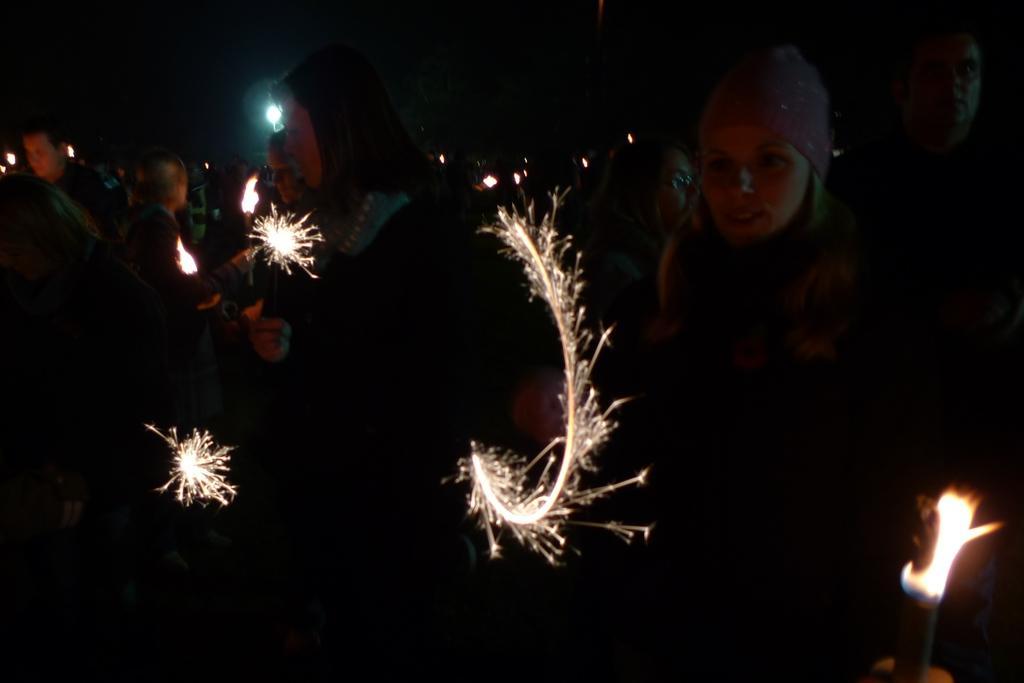In one or two sentences, can you explain what this image depicts? In this picture I can observe some people. Some of them are holding candles and some of them are firing crackers in their hands. The background is dark. 